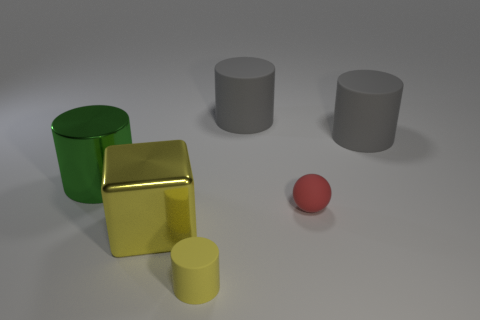Are there any patterns or consistencies in the colors of the objects? There is a clear pattern in the color arrangement. Each object has a distinct, solid color: green, golden, yellow, red, and grey. The colors do not repeat, and no object shares a hue with another, providing a spectrum of colors that presumably serve to distinguish the objects clearly from one another. 